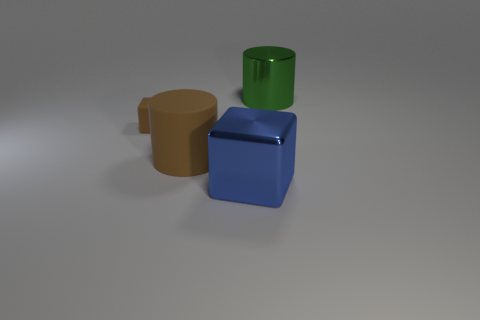Subtract 1 cylinders. How many cylinders are left? 1 Add 2 small cyan metallic things. How many objects exist? 6 Subtract 0 purple cylinders. How many objects are left? 4 Subtract all brown cylinders. Subtract all brown balls. How many cylinders are left? 1 Subtract all red cylinders. How many green blocks are left? 0 Subtract all small purple metal cubes. Subtract all big blue metal blocks. How many objects are left? 3 Add 1 tiny rubber objects. How many tiny rubber objects are left? 2 Add 1 large blue metal things. How many large blue metal things exist? 2 